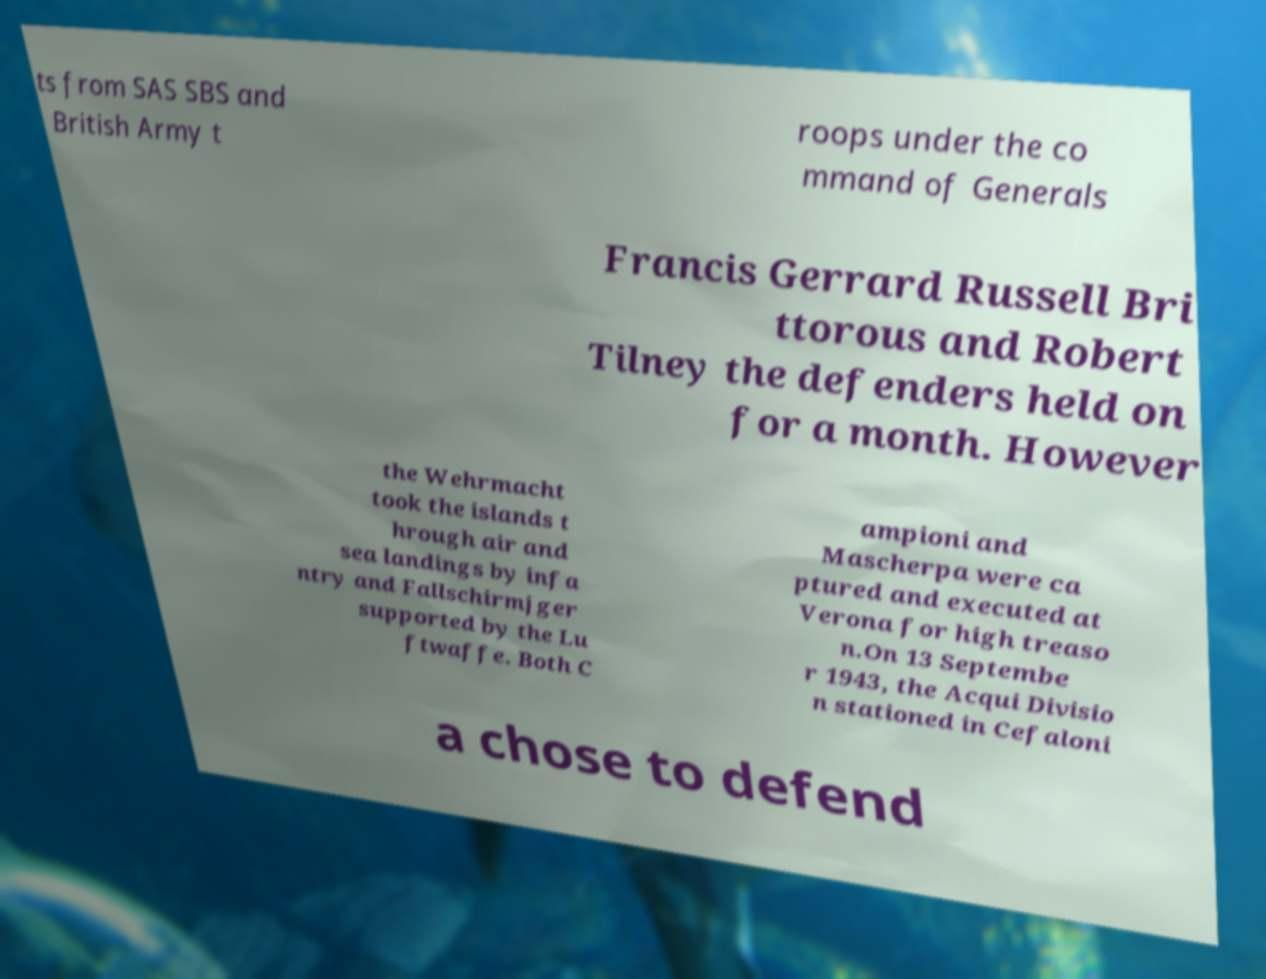Please identify and transcribe the text found in this image. ts from SAS SBS and British Army t roops under the co mmand of Generals Francis Gerrard Russell Bri ttorous and Robert Tilney the defenders held on for a month. However the Wehrmacht took the islands t hrough air and sea landings by infa ntry and Fallschirmjger supported by the Lu ftwaffe. Both C ampioni and Mascherpa were ca ptured and executed at Verona for high treaso n.On 13 Septembe r 1943, the Acqui Divisio n stationed in Cefaloni a chose to defend 